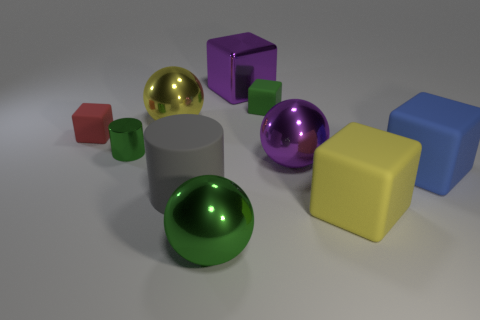Subtract all blue cubes. How many cubes are left? 4 Subtract all green rubber blocks. How many blocks are left? 4 Subtract all green cubes. Subtract all green cylinders. How many cubes are left? 4 Subtract all balls. How many objects are left? 7 Subtract all shiny blocks. Subtract all red rubber things. How many objects are left? 8 Add 4 red matte objects. How many red matte objects are left? 5 Add 8 big purple metallic things. How many big purple metallic things exist? 10 Subtract 0 brown spheres. How many objects are left? 10 